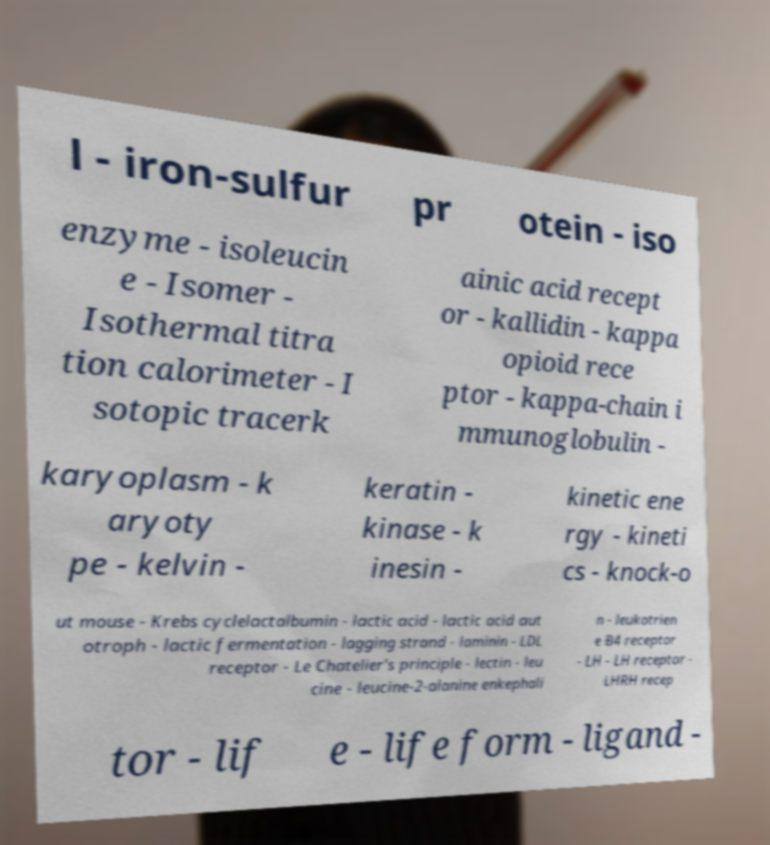What messages or text are displayed in this image? I need them in a readable, typed format. l - iron-sulfur pr otein - iso enzyme - isoleucin e - Isomer - Isothermal titra tion calorimeter - I sotopic tracerk ainic acid recept or - kallidin - kappa opioid rece ptor - kappa-chain i mmunoglobulin - karyoplasm - k aryoty pe - kelvin - keratin - kinase - k inesin - kinetic ene rgy - kineti cs - knock-o ut mouse - Krebs cyclelactalbumin - lactic acid - lactic acid aut otroph - lactic fermentation - lagging strand - laminin - LDL receptor - Le Chatelier's principle - lectin - leu cine - leucine-2-alanine enkephali n - leukotrien e B4 receptor - LH - LH receptor - LHRH recep tor - lif e - life form - ligand - 